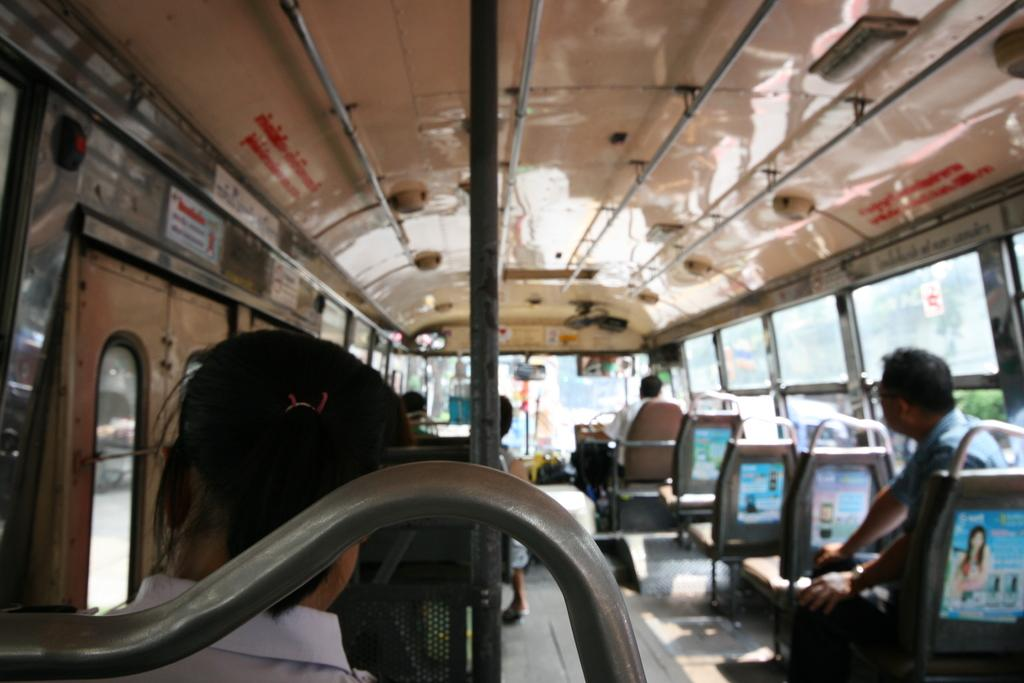What type of vehicle is shown in the image? The image shows an inner view of a bus. Who is present in the image? There is a bus driver in the image. Where is the bus driver located in the bus? The bus driver is sitting near the steering wheel. Are there any passengers in the bus? Yes, there are other people sitting on chairs in the bus. Is there a veil covering any part of the bus in the image? No, there is no veil present in the image. 